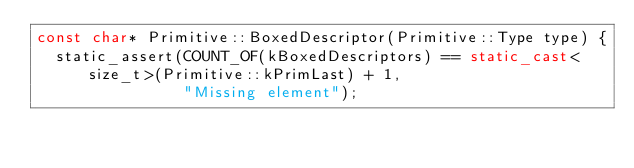<code> <loc_0><loc_0><loc_500><loc_500><_C++_>const char* Primitive::BoxedDescriptor(Primitive::Type type) {
  static_assert(COUNT_OF(kBoxedDescriptors) == static_cast<size_t>(Primitive::kPrimLast) + 1,
                "Missing element");</code> 